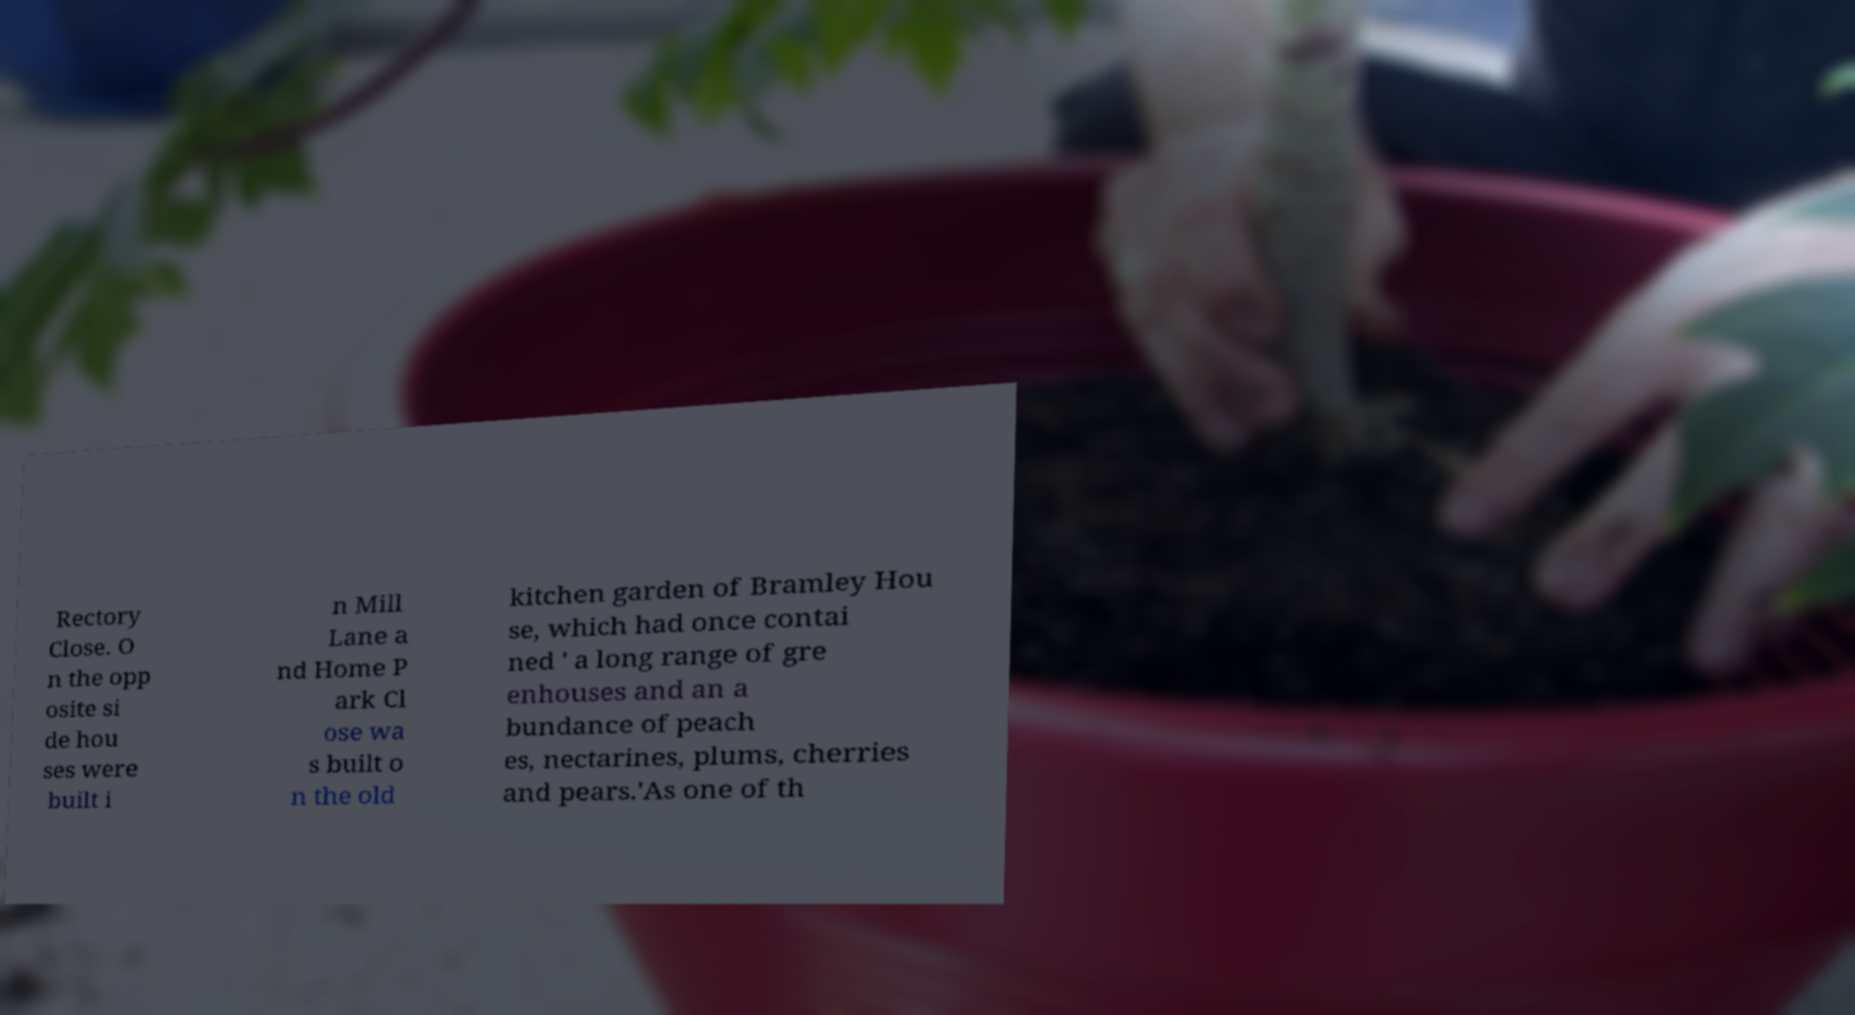There's text embedded in this image that I need extracted. Can you transcribe it verbatim? Rectory Close. O n the opp osite si de hou ses were built i n Mill Lane a nd Home P ark Cl ose wa s built o n the old kitchen garden of Bramley Hou se, which had once contai ned ' a long range of gre enhouses and an a bundance of peach es, nectarines, plums, cherries and pears.'As one of th 